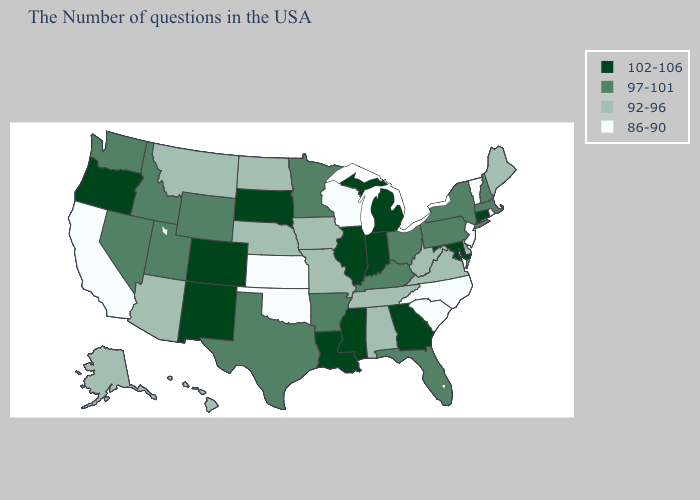What is the value of Virginia?
Write a very short answer. 92-96. Does Massachusetts have the highest value in the USA?
Give a very brief answer. No. Which states have the lowest value in the USA?
Short answer required. Rhode Island, Vermont, New Jersey, North Carolina, South Carolina, Wisconsin, Kansas, Oklahoma, California. Does the map have missing data?
Write a very short answer. No. What is the value of Montana?
Write a very short answer. 92-96. Name the states that have a value in the range 86-90?
Short answer required. Rhode Island, Vermont, New Jersey, North Carolina, South Carolina, Wisconsin, Kansas, Oklahoma, California. Name the states that have a value in the range 86-90?
Write a very short answer. Rhode Island, Vermont, New Jersey, North Carolina, South Carolina, Wisconsin, Kansas, Oklahoma, California. What is the value of New York?
Short answer required. 97-101. Name the states that have a value in the range 92-96?
Give a very brief answer. Maine, Delaware, Virginia, West Virginia, Alabama, Tennessee, Missouri, Iowa, Nebraska, North Dakota, Montana, Arizona, Alaska, Hawaii. Does Connecticut have the same value as Alaska?
Concise answer only. No. Does the map have missing data?
Short answer required. No. Which states have the highest value in the USA?
Answer briefly. Connecticut, Maryland, Georgia, Michigan, Indiana, Illinois, Mississippi, Louisiana, South Dakota, Colorado, New Mexico, Oregon. Name the states that have a value in the range 86-90?
Quick response, please. Rhode Island, Vermont, New Jersey, North Carolina, South Carolina, Wisconsin, Kansas, Oklahoma, California. Does Washington have a higher value than Florida?
Give a very brief answer. No. What is the value of North Carolina?
Concise answer only. 86-90. 